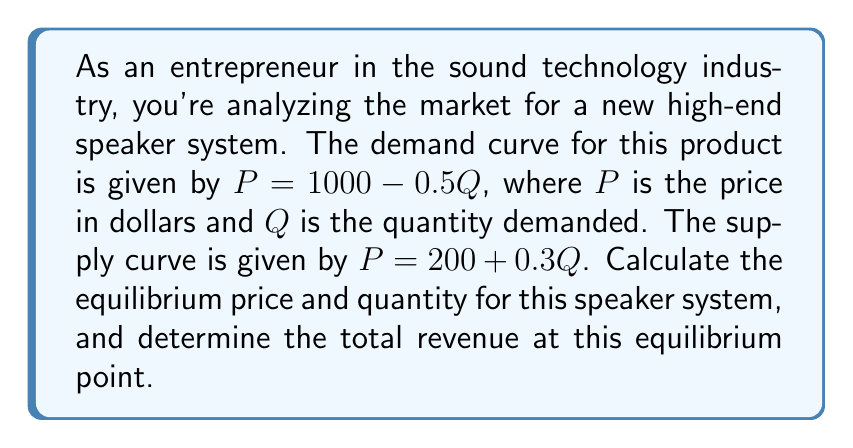Teach me how to tackle this problem. To solve this problem, we need to follow these steps:

1) Find the equilibrium point by equating the supply and demand curves:
   
   Demand: $P = 1000 - 0.5Q$
   Supply: $P = 200 + 0.3Q$
   
   At equilibrium: $1000 - 0.5Q = 200 + 0.3Q$

2) Solve for Q:
   
   $1000 - 200 = 0.3Q + 0.5Q$
   $800 = 0.8Q$
   $Q = 1000$

3) Find the equilibrium price by substituting Q into either equation:
   
   $P = 1000 - 0.5(1000) = 500$

   Or: $P = 200 + 0.3(1000) = 500$

4) Calculate the total revenue at equilibrium:
   
   Total Revenue = Price × Quantity
   $TR = 500 × 1000 = 500,000$

[asy]
import graph;
size(200,200);
real f(real x) {return 1000-0.5x;}
real g(real x) {return 200+0.3x;}
draw(graph(f,0,2000));
draw(graph(g,0,2000));
xaxis("Q",0,2000,arrow=Arrow);
yaxis("P",0,1000,arrow=Arrow);
dot((1000,500));
label("Equilibrium",(1000,500),NE);
[/asy]
Answer: The equilibrium price is $500, the equilibrium quantity is 1000 units, and the total revenue at equilibrium is $500,000. 